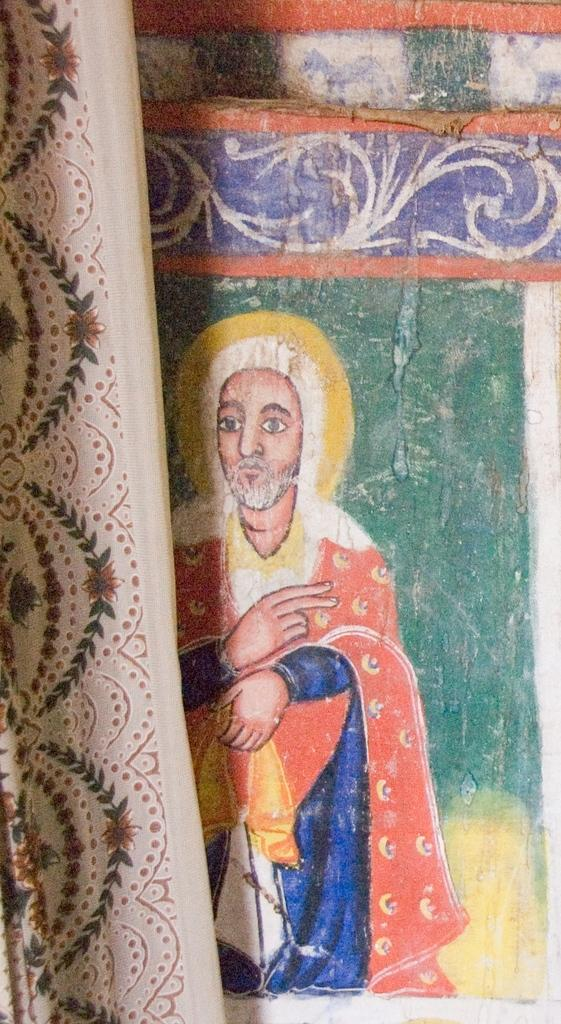What is located in the center of the image? There is a curtain in the center of the image. What can be seen behind the curtain? There is a wall in the image. What is on the wall? There is a painting on the wall. Who or what is depicted in the painting? The painting depicts a person. What type of tree is growing in the painting? There is no tree present in the painting; it depicts a person. What is being served for dinner in the image? There is no dinner being served in the image; it features a curtain, a wall, a painting, and a person. 